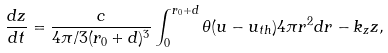<formula> <loc_0><loc_0><loc_500><loc_500>\frac { d z } { d t } = \frac { c } { 4 \pi / 3 ( r _ { 0 } + d ) ^ { 3 } } \int _ { 0 } ^ { r _ { 0 } + d } \theta ( u - u _ { t h } ) 4 \pi r ^ { 2 } d r - k _ { z } z ,</formula> 